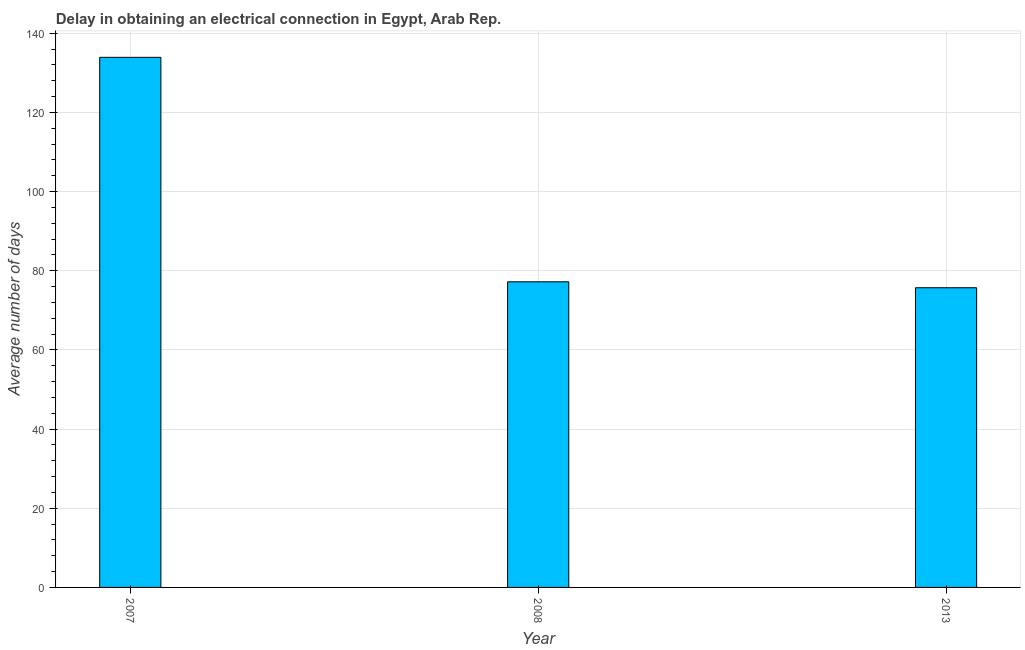Does the graph contain grids?
Make the answer very short. Yes. What is the title of the graph?
Your answer should be very brief. Delay in obtaining an electrical connection in Egypt, Arab Rep. What is the label or title of the X-axis?
Provide a short and direct response. Year. What is the label or title of the Y-axis?
Provide a succinct answer. Average number of days. What is the dalay in electrical connection in 2007?
Provide a succinct answer. 133.9. Across all years, what is the maximum dalay in electrical connection?
Provide a succinct answer. 133.9. Across all years, what is the minimum dalay in electrical connection?
Ensure brevity in your answer.  75.7. In which year was the dalay in electrical connection maximum?
Make the answer very short. 2007. In which year was the dalay in electrical connection minimum?
Give a very brief answer. 2013. What is the sum of the dalay in electrical connection?
Offer a very short reply. 286.8. What is the difference between the dalay in electrical connection in 2007 and 2013?
Give a very brief answer. 58.2. What is the average dalay in electrical connection per year?
Offer a very short reply. 95.6. What is the median dalay in electrical connection?
Your answer should be compact. 77.2. Is the difference between the dalay in electrical connection in 2007 and 2013 greater than the difference between any two years?
Provide a short and direct response. Yes. What is the difference between the highest and the second highest dalay in electrical connection?
Offer a very short reply. 56.7. What is the difference between the highest and the lowest dalay in electrical connection?
Offer a very short reply. 58.2. What is the Average number of days in 2007?
Provide a short and direct response. 133.9. What is the Average number of days in 2008?
Give a very brief answer. 77.2. What is the Average number of days of 2013?
Provide a succinct answer. 75.7. What is the difference between the Average number of days in 2007 and 2008?
Make the answer very short. 56.7. What is the difference between the Average number of days in 2007 and 2013?
Provide a succinct answer. 58.2. What is the difference between the Average number of days in 2008 and 2013?
Keep it short and to the point. 1.5. What is the ratio of the Average number of days in 2007 to that in 2008?
Provide a short and direct response. 1.73. What is the ratio of the Average number of days in 2007 to that in 2013?
Provide a succinct answer. 1.77. 